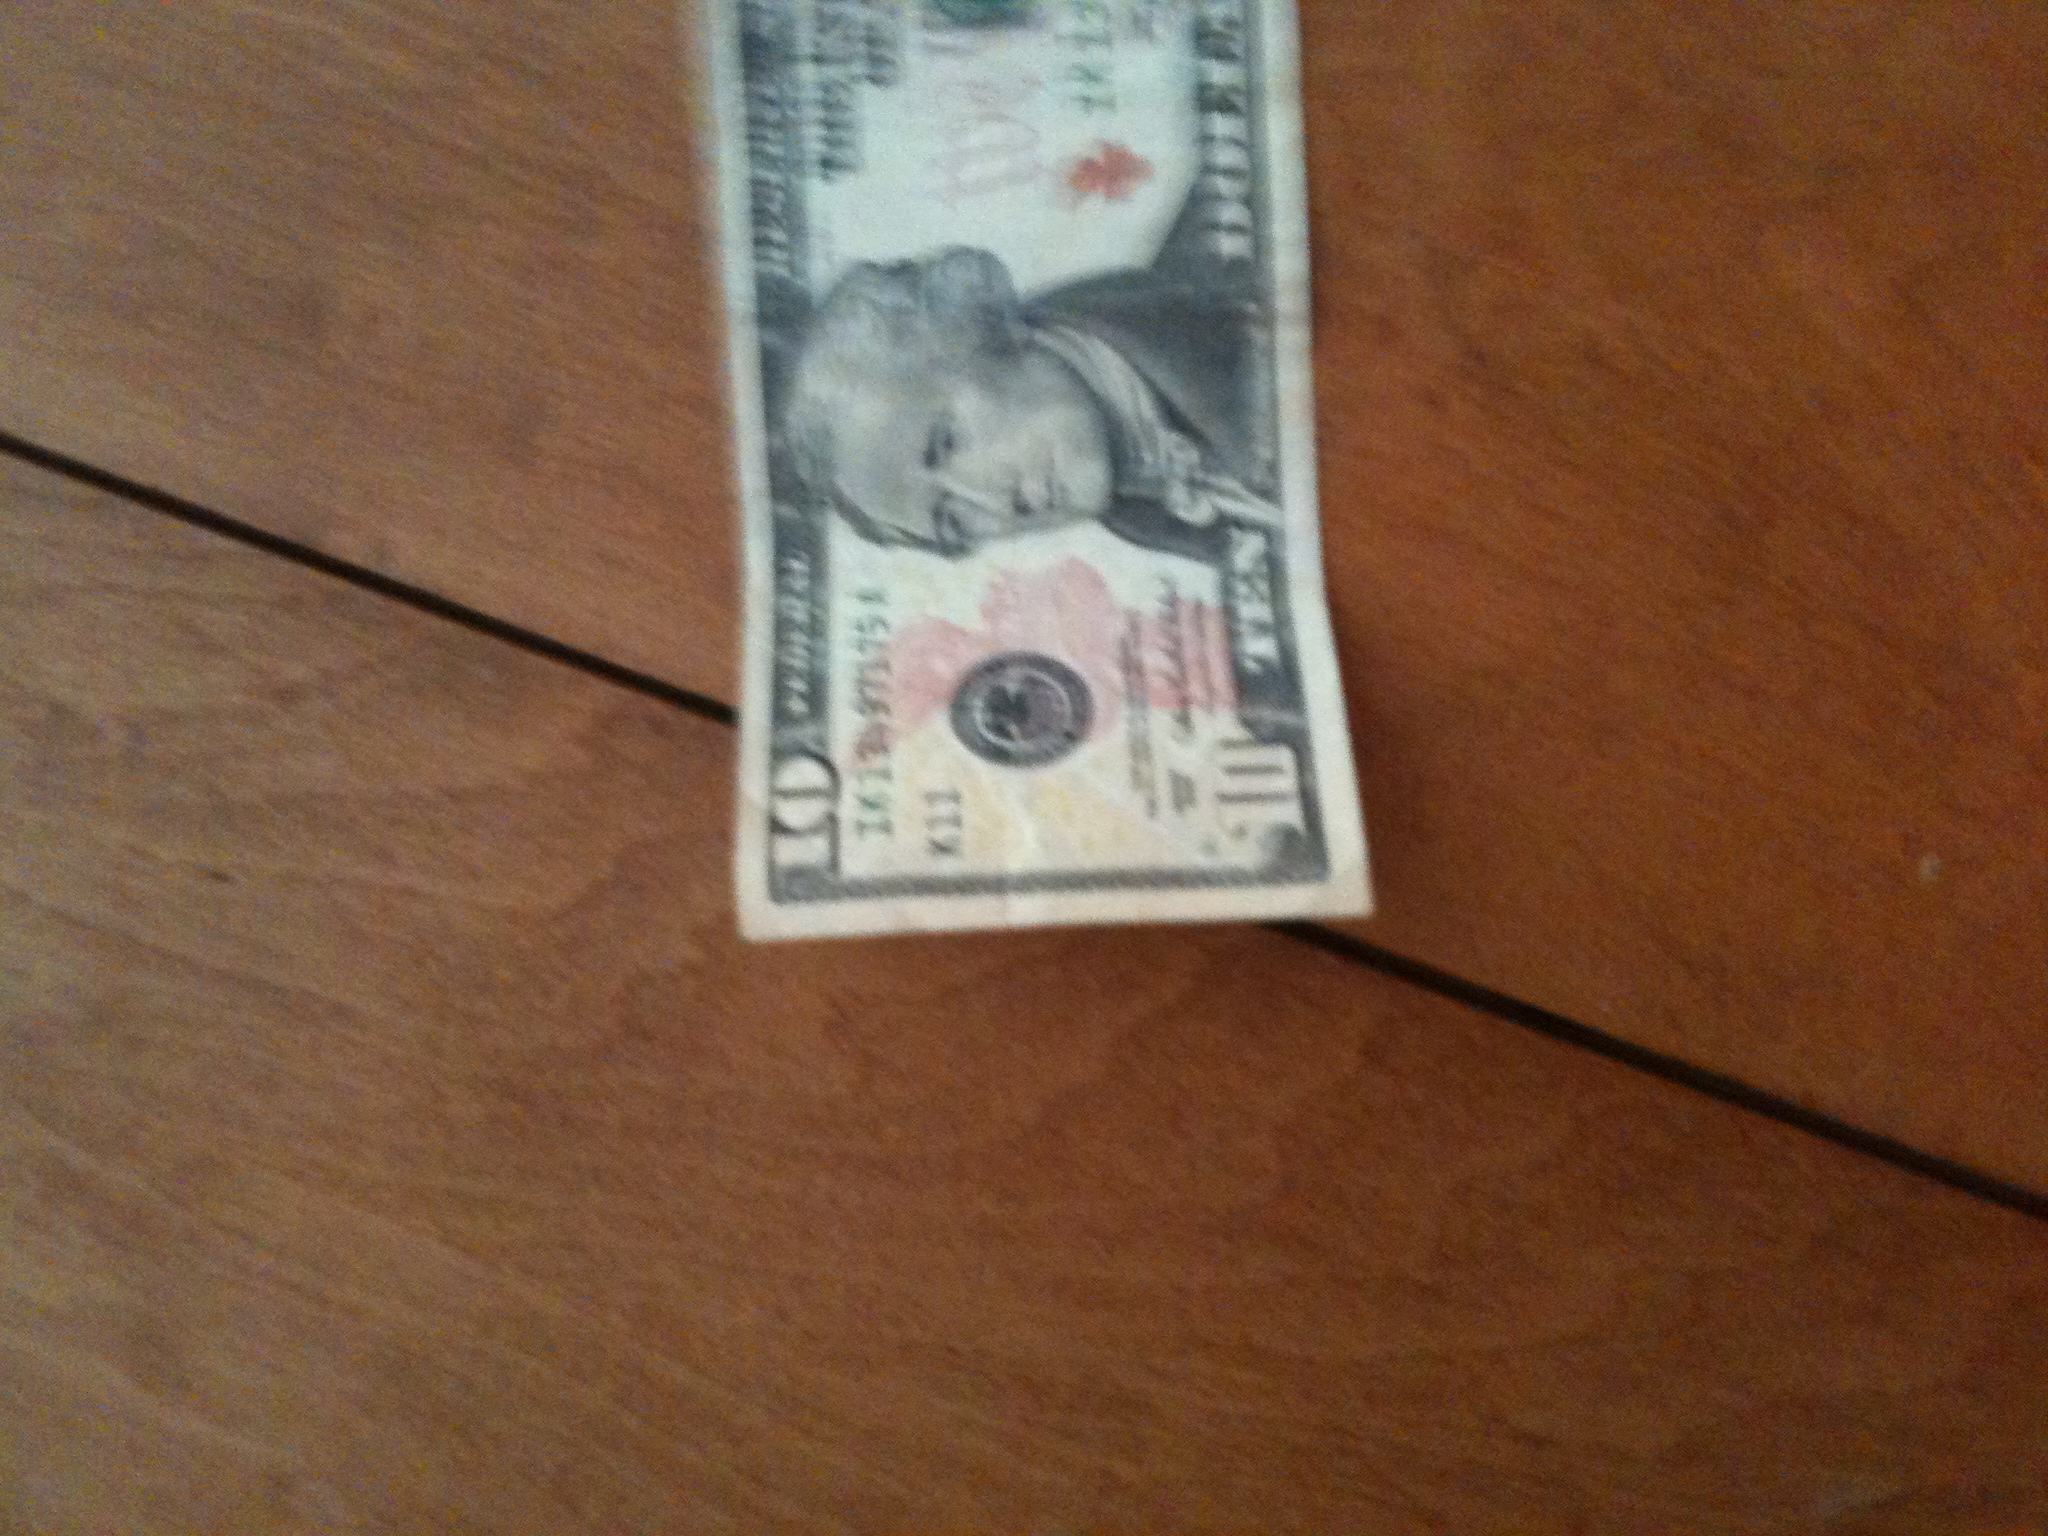What denomination is this bill? This is a 10-dollar bill, as indicated by the number '10' visible on its corners. Can you describe any special features on this bill? Indeed. The 10-dollar bill features the portrait of Alexander Hamilton, one of the Founding Fathers of the United States. Additionally, it includes several anti-counterfeiting features such as a watermark, security thread, and color-shifting ink. 